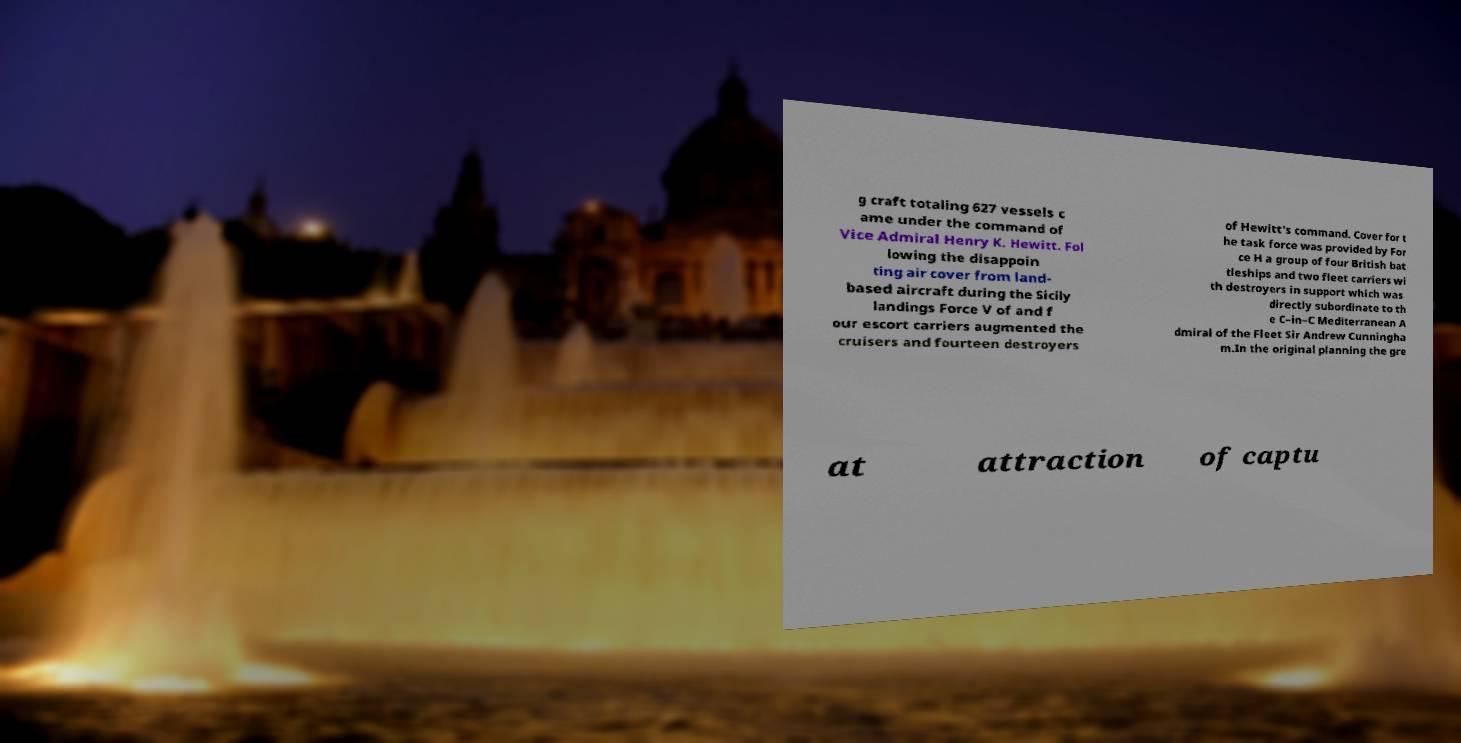Please identify and transcribe the text found in this image. g craft totaling 627 vessels c ame under the command of Vice Admiral Henry K. Hewitt. Fol lowing the disappoin ting air cover from land- based aircraft during the Sicily landings Force V of and f our escort carriers augmented the cruisers and fourteen destroyers of Hewitt's command. Cover for t he task force was provided by For ce H a group of four British bat tleships and two fleet carriers wi th destroyers in support which was directly subordinate to th e C–in–C Mediterranean A dmiral of the Fleet Sir Andrew Cunningha m.In the original planning the gre at attraction of captu 